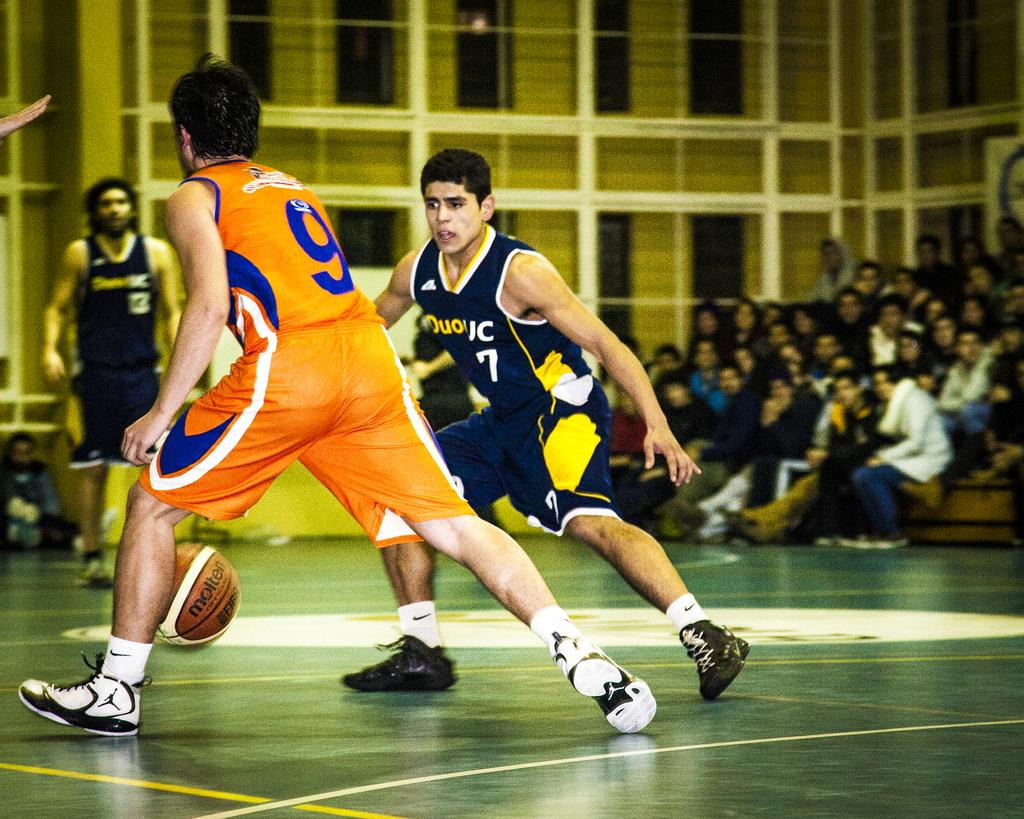What activity are the persons in the image engaged in? The persons in the image are playing volleyball. Can you describe the setting of the image? The image shows a volleyball game with audience members in the right corner. What type of arch can be seen in the image? There is no arch present in the image; it features a volleyball game with audience members. What grade level is the volleyball game being played at? The image does not provide information about the grade level of the volleyball game. 